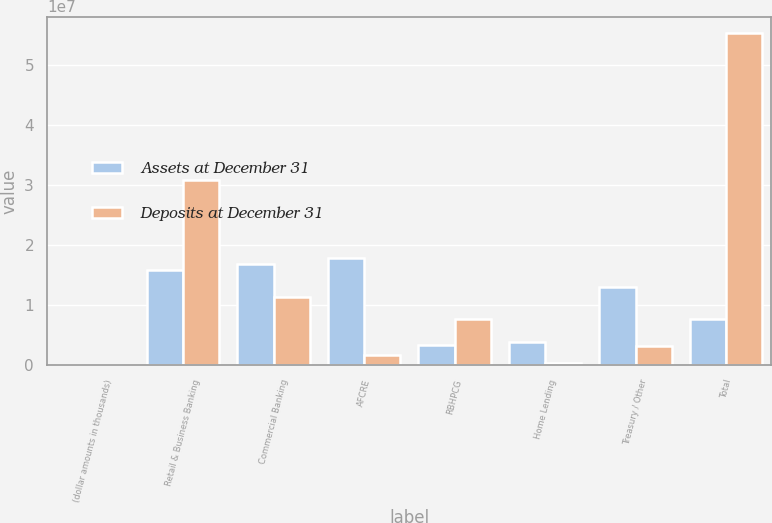<chart> <loc_0><loc_0><loc_500><loc_500><stacked_bar_chart><ecel><fcel>(dollar amounts in thousands)<fcel>Retail & Business Banking<fcel>Commercial Banking<fcel>AFCRE<fcel>RBHPCG<fcel>Home Lending<fcel>Treasury / Other<fcel>Total<nl><fcel>Assets at December 31<fcel>2015<fcel>1.58226e+07<fcel>1.69435e+07<fcel>1.78556e+07<fcel>3.45885e+06<fcel>3.9172e+06<fcel>1.30469e+07<fcel>7.69058e+06<nl><fcel>Deposits at December 31<fcel>2015<fcel>3.08756e+07<fcel>1.14248e+07<fcel>1.6517e+06<fcel>7.69058e+06<fcel>361881<fcel>3.29043e+06<fcel>5.5295e+07<nl></chart> 